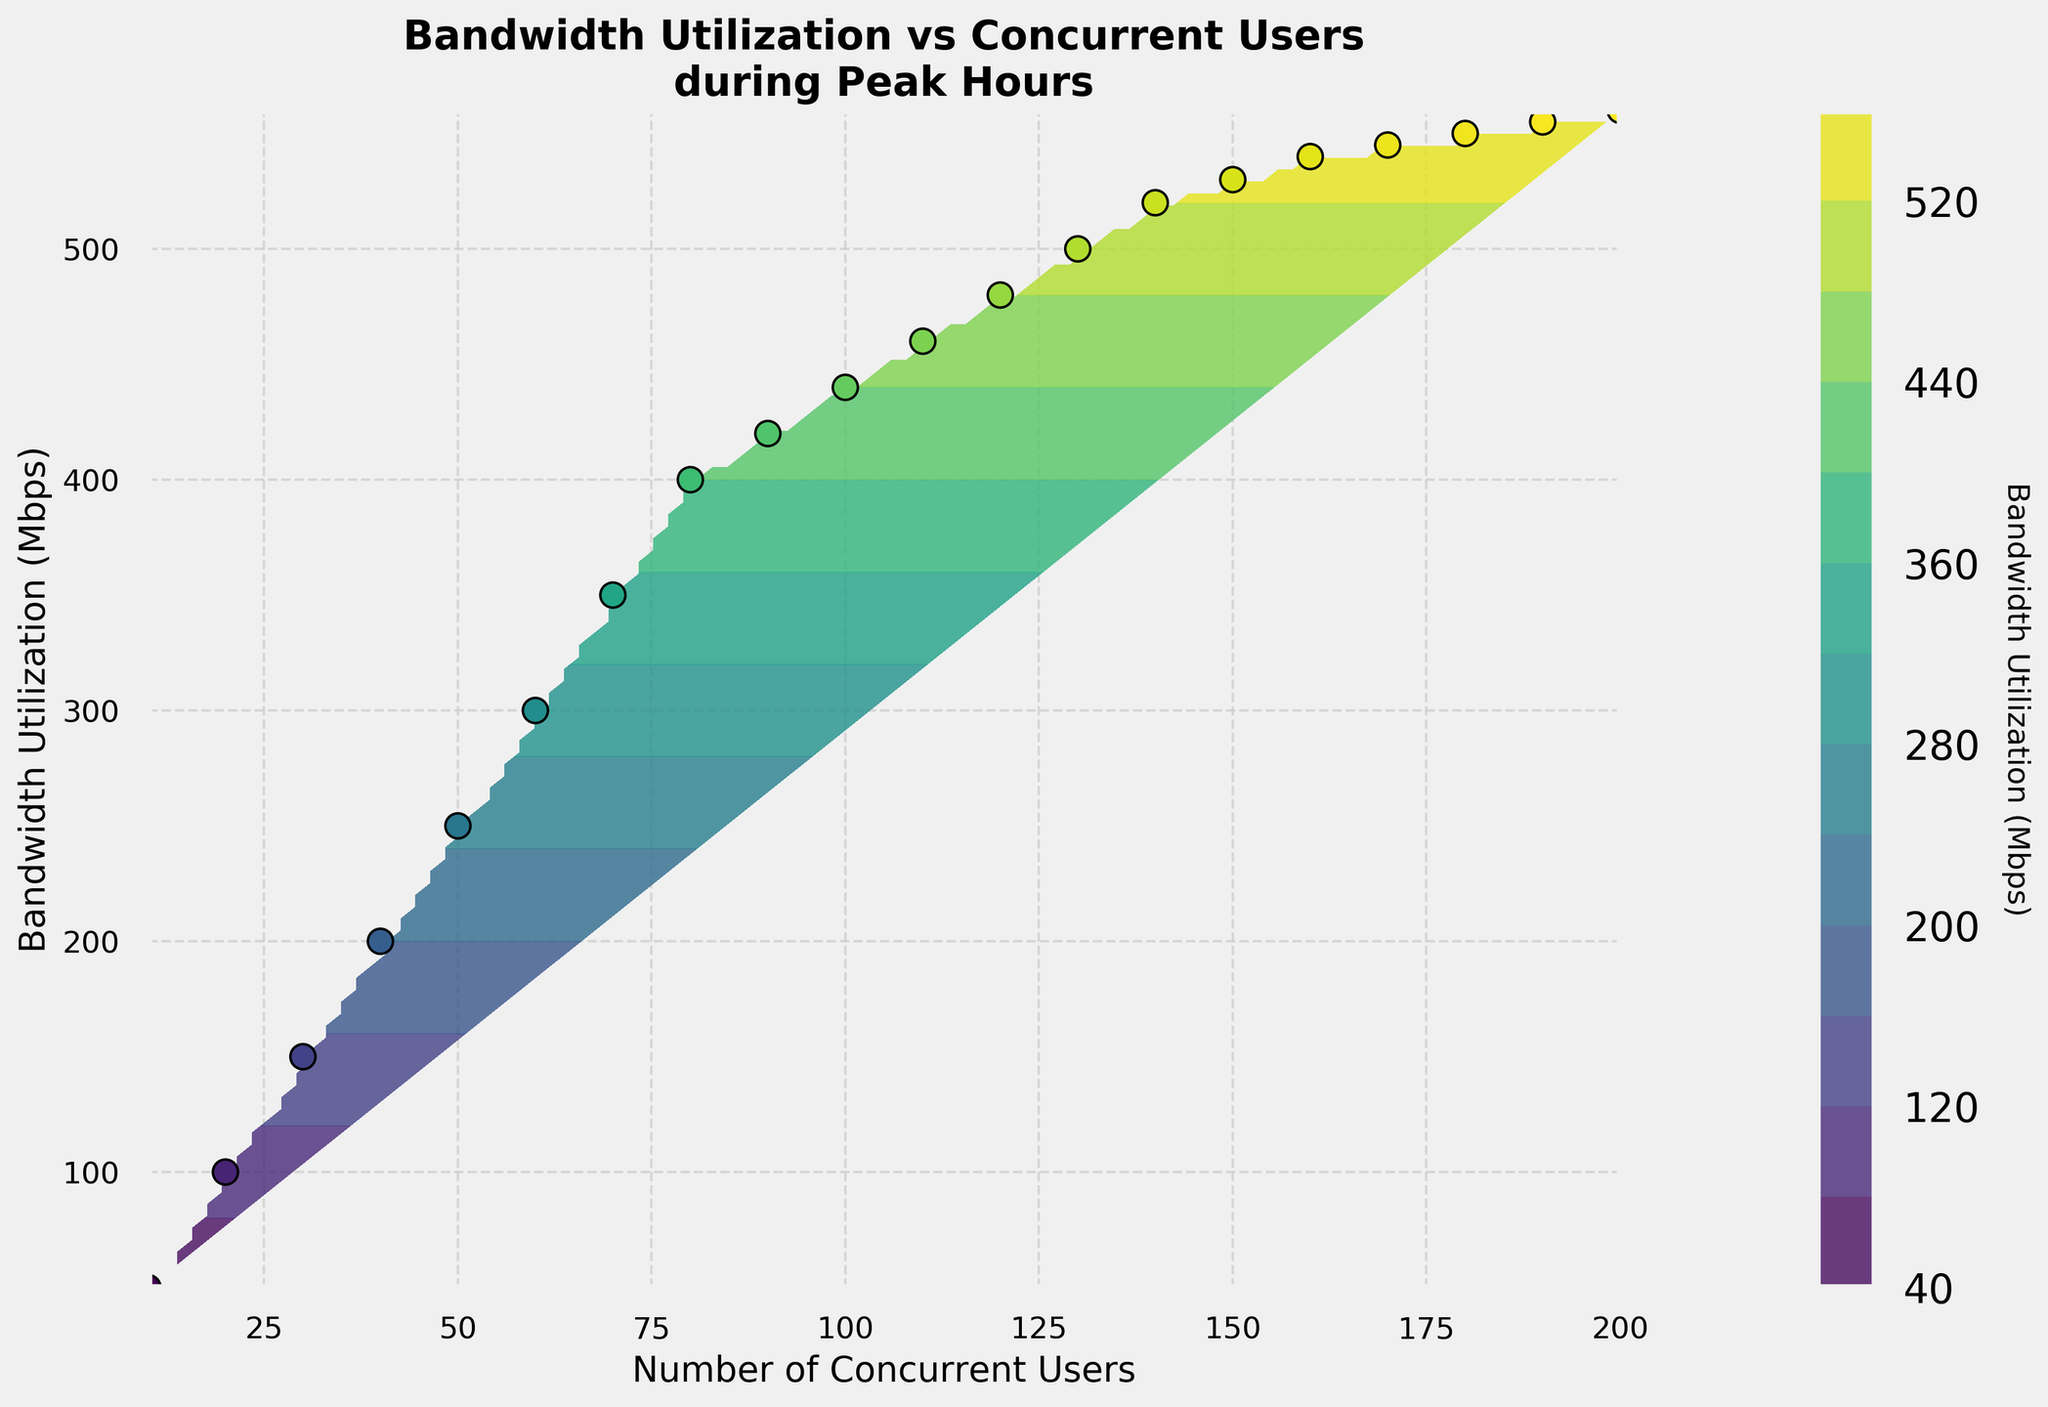What's the title of the plot? The title of the plot is located at the top of the figure. It is written in bold and larger font size than other text in the figure so it easily stands out.
Answer: Bandwidth Utilization vs Concurrent Users during Peak Hours What are the labels for the x-axis and y-axis? The labels for the axes are located along the x-axis and y-axis. The x-axis label describes what is measured along the horizontal axis, and the y-axis label describes the vertical axis measurement.
Answer: The x-axis is labeled "Number of Concurrent Users", and the y-axis is labeled "Bandwidth Utilization (Mbps)" What does the color bar represent? The color bar is located to the side of the contour plot and it shows the color gradient scale used in the plot. The label on the color bar indicates what measurement is represented by the various colors.
Answer: The color bar represents "Bandwidth Utilization (Mbps)" How does the Bandwidth Utilization change as the Number of Concurrent Users increases? To answer this, observe the contour lines and the trend of the data points. As the number of concurrent users increases from left to right, the color gradient moves from dark to light, indicating an increase in bandwidth utilization.
Answer: Bandwidth Utilization increases as the Number of Concurrent Users increases At what number of concurrent users does the Bandwidth Utilization exceed 500 Mbps? To find this, look at where the y-coordinate exceeds 500 Mbps and find the corresponding x-coordinate. The point where the contour line crosses the 500 Mbps line corresponds to between 120 and 140 concurrent users.
Answer: Between 130 and 140 concurrent users What's the Bandwidth Utilization for 150 concurrent users? Locate the data point on the x-axis where the Number of Concurrent Users is 150, then look vertically upward to see where it intersects with the y-axis or observe the corresponding value in the color gradient.
Answer: Approximately 530 Mbps Compare the Bandwidth Utilization between 50 and 100 concurrent users. Find the data points for 50 and 100 concurrent users and compare their corresponding y-values. For 50 concurrent users, the Bandwidth Utilization is around 250 Mbps, and for 100 concurrent users, it is around 440 Mbps.
Answer: 440 Mbps is higher than 250 Mbps How many data points are plotted on the scatter plot? Count the individual data points on the scatter plot. Each point represents a specific number of concurrent users and its corresponding bandwidth utilization. There should be 20 such points given the data provided.
Answer: 20 data points What contour level corresponds to a Bandwidth Utilization of 540 Mbps? Look at the contour lines and their corresponding color bar to see which line crosses the y-axis value of 540 Mbps. Observe the specific contours and refer to the color gradient.
Answer: The contour level for 540 Mbps 